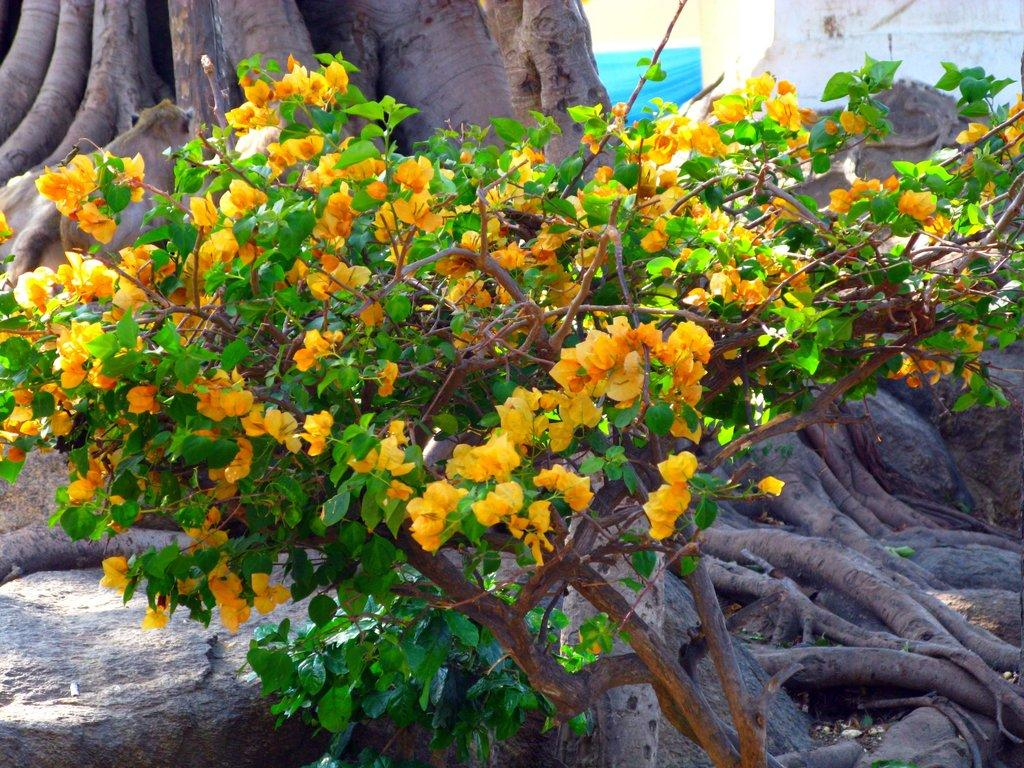What is located in the foreground of the image? There are flowers in the foreground of the image. What is the flowers' proximity to another object in the image? The flowers are near a tree. What part of the tree is visible in the background of the image? There is a tree trunk visible in the background of the image. What type of living creature can be seen in the background of the image? There is an animal in the background of the image. Where is the bath located in the image? There is no bath present in the image. How many horses are visible in the image? There are no horses visible in the image. 